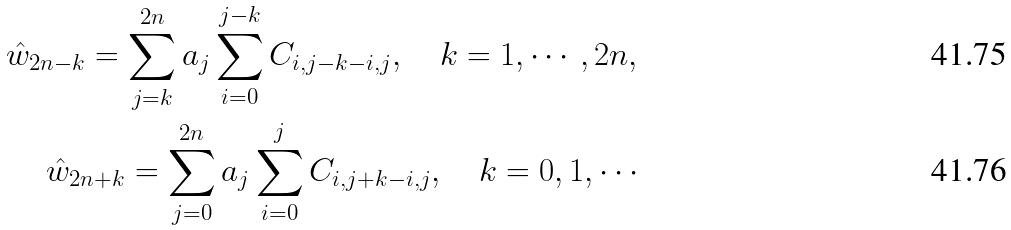Convert formula to latex. <formula><loc_0><loc_0><loc_500><loc_500>\hat { w } _ { 2 n - k } = \sum ^ { 2 n } _ { j = k } a _ { j } \sum _ { i = 0 } ^ { j - k } C _ { i , j - k - i , j } , \quad k = 1 , \cdots , 2 n , \\ \hat { w } _ { 2 n + k } = \sum ^ { 2 n } _ { j = 0 } a _ { j } \sum _ { i = 0 } ^ { j } C _ { i , j + k - i , j } , \quad k = 0 , 1 , \cdots</formula> 